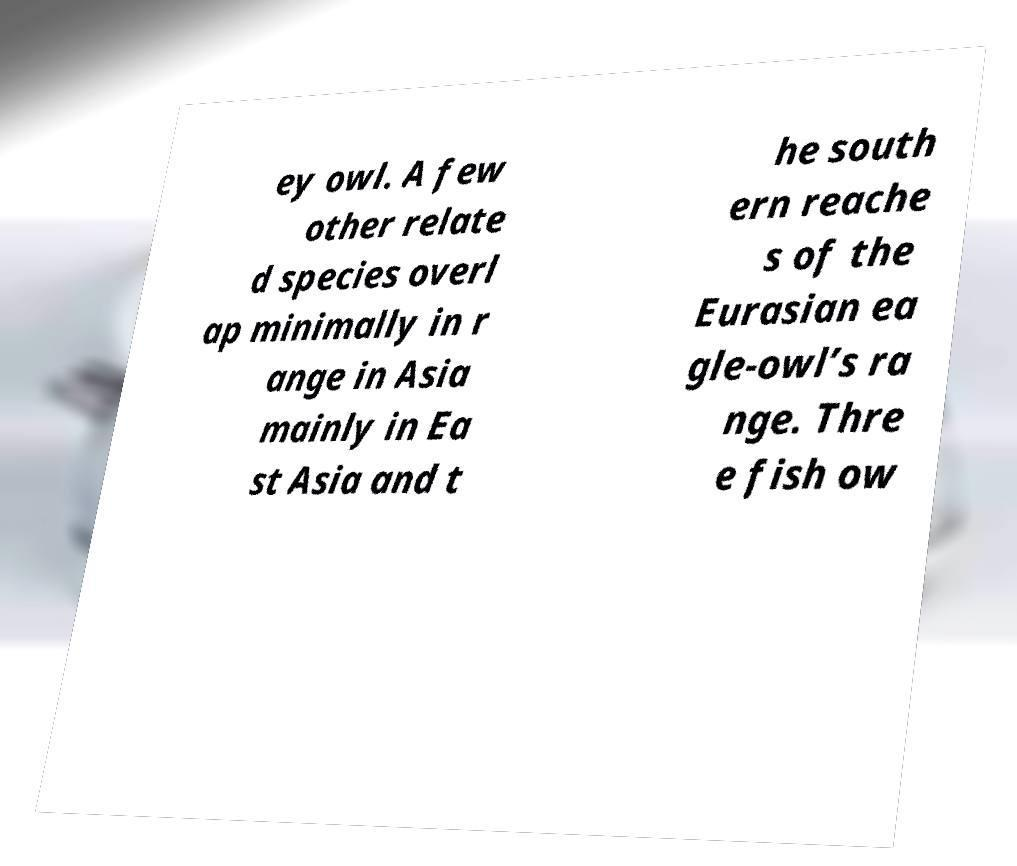I need the written content from this picture converted into text. Can you do that? ey owl. A few other relate d species overl ap minimally in r ange in Asia mainly in Ea st Asia and t he south ern reache s of the Eurasian ea gle-owl’s ra nge. Thre e fish ow 